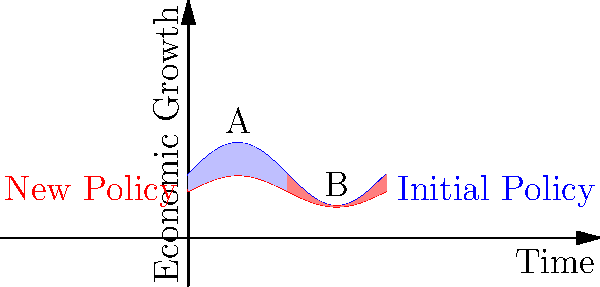The graph shows the economic growth rate under two different policy regimes over time. The blue curve represents the initial policy, and the red curve represents a new policy implemented at time $t = \pi$. The shaded areas represent the cumulative effect of each policy on economic growth.

Calculate the difference between the cumulative effects of the two policies by evaluating the integral:

$$\int_0^{2\pi} (f(t) - g(t)) dt$$

where $f(t) = 2 + \sin(t)$ and $g(t) = 1.5 + 0.5\sin(t)$.

What does this result tell us about the overall impact of the policy change on economic growth? To solve this problem, we'll follow these steps:

1) The integral we need to evaluate is:
   $$\int_0^{2\pi} (f(t) - g(t)) dt = \int_0^{2\pi} ((2 + \sin(t)) - (1.5 + 0.5\sin(t))) dt$$

2) Simplify the integrand:
   $$\int_0^{2\pi} (0.5 + 0.5\sin(t)) dt$$

3) Integrate:
   $$[0.5t - 0.5\cos(t)]_0^{2\pi}$$

4) Evaluate the bounds:
   $$(0.5(2\pi) - 0.5\cos(2\pi)) - (0.5(0) - 0.5\cos(0))$$
   $$= \pi - 0.5 + 0.5 = \pi$$

5) Interpret the result:
   The positive value of $\pi$ indicates that the area between the blue curve and the red curve above the intersection point is larger than the area below the intersection point. This means that the cumulative effect of the initial policy (blue) on economic growth is greater than that of the new policy (red) over the given time period.

The difference of $\pi$ units of cumulative economic growth suggests that the policy change has resulted in a net decrease in economic growth over the observed period. This quantitative analysis provides a clear measure of the policy's impact, supporting the need for transparency and accountability in government decision-making.
Answer: $\pi$ units of decreased cumulative economic growth 